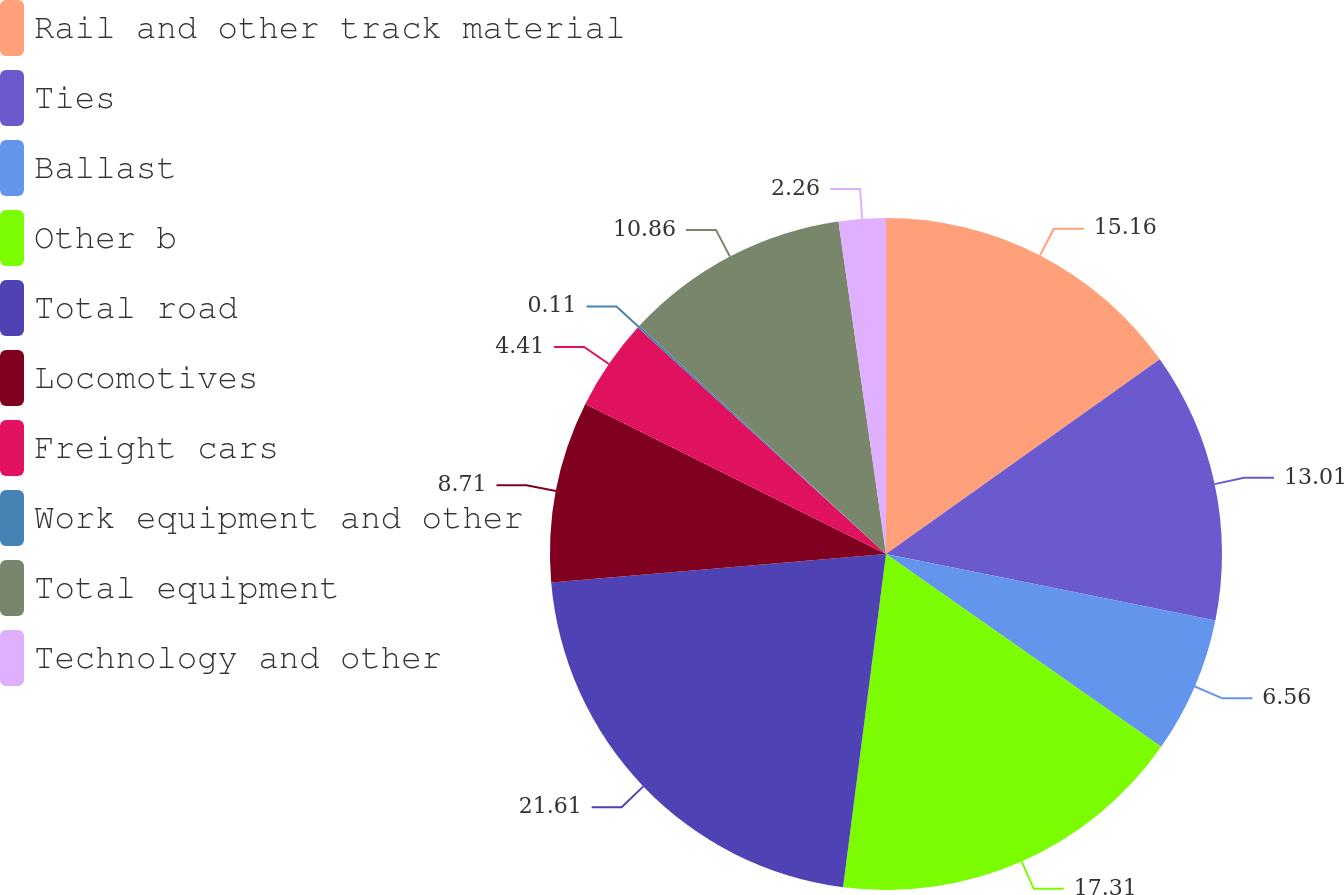Convert chart. <chart><loc_0><loc_0><loc_500><loc_500><pie_chart><fcel>Rail and other track material<fcel>Ties<fcel>Ballast<fcel>Other b<fcel>Total road<fcel>Locomotives<fcel>Freight cars<fcel>Work equipment and other<fcel>Total equipment<fcel>Technology and other<nl><fcel>15.16%<fcel>13.01%<fcel>6.56%<fcel>17.31%<fcel>21.61%<fcel>8.71%<fcel>4.41%<fcel>0.11%<fcel>10.86%<fcel>2.26%<nl></chart> 